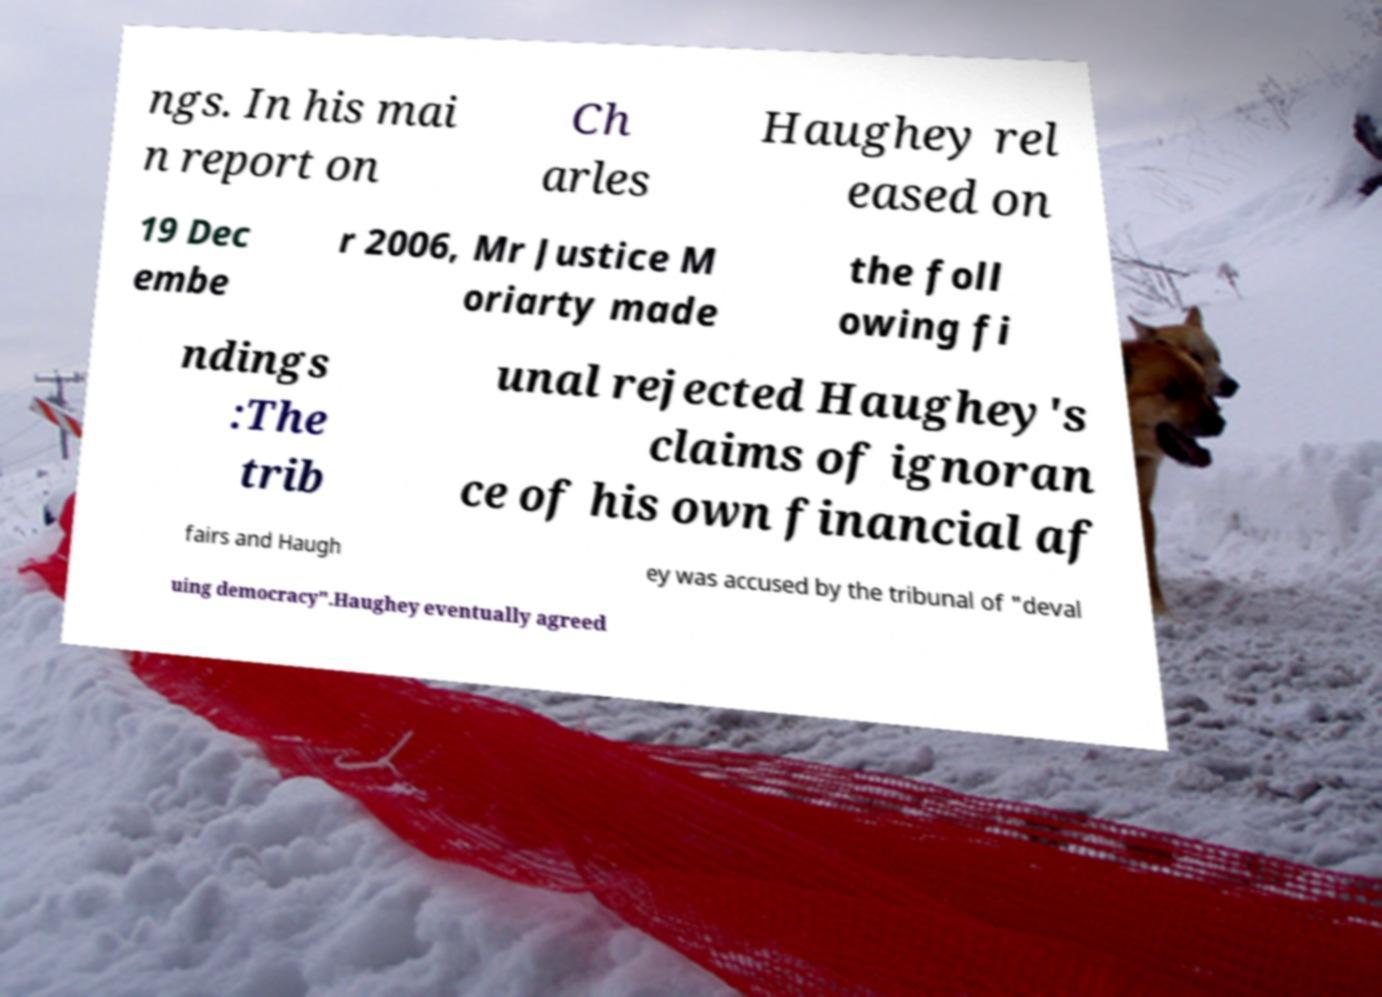What messages or text are displayed in this image? I need them in a readable, typed format. ngs. In his mai n report on Ch arles Haughey rel eased on 19 Dec embe r 2006, Mr Justice M oriarty made the foll owing fi ndings :The trib unal rejected Haughey's claims of ignoran ce of his own financial af fairs and Haugh ey was accused by the tribunal of "deval uing democracy".Haughey eventually agreed 